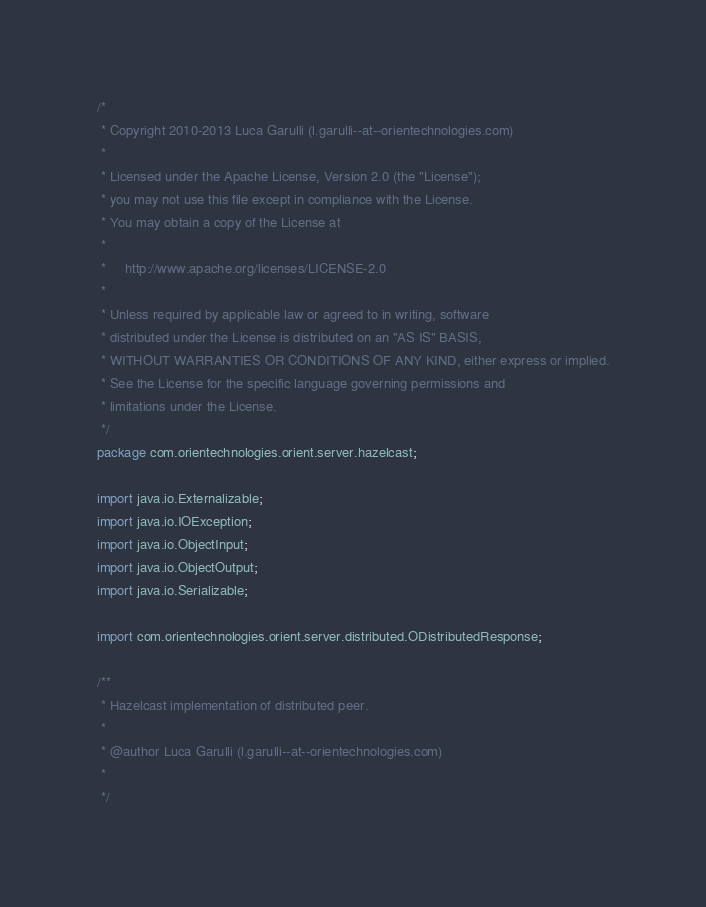<code> <loc_0><loc_0><loc_500><loc_500><_Java_>/*
 * Copyright 2010-2013 Luca Garulli (l.garulli--at--orientechnologies.com)
 *
 * Licensed under the Apache License, Version 2.0 (the "License");
 * you may not use this file except in compliance with the License.
 * You may obtain a copy of the License at
 *
 *     http://www.apache.org/licenses/LICENSE-2.0
 *
 * Unless required by applicable law or agreed to in writing, software
 * distributed under the License is distributed on an "AS IS" BASIS,
 * WITHOUT WARRANTIES OR CONDITIONS OF ANY KIND, either express or implied.
 * See the License for the specific language governing permissions and
 * limitations under the License.
 */
package com.orientechnologies.orient.server.hazelcast;

import java.io.Externalizable;
import java.io.IOException;
import java.io.ObjectInput;
import java.io.ObjectOutput;
import java.io.Serializable;

import com.orientechnologies.orient.server.distributed.ODistributedResponse;

/**
 * Hazelcast implementation of distributed peer.
 * 
 * @author Luca Garulli (l.garulli--at--orientechnologies.com)
 * 
 */</code> 